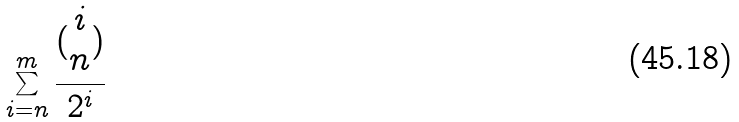Convert formula to latex. <formula><loc_0><loc_0><loc_500><loc_500>\sum _ { i = n } ^ { m } \frac { ( \begin{matrix} i \\ n \end{matrix} ) } { 2 ^ { i } }</formula> 